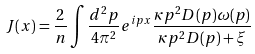<formula> <loc_0><loc_0><loc_500><loc_500>J ( x ) = \frac { 2 } { n } \int \frac { d ^ { 2 } p } { 4 \pi ^ { 2 } } e ^ { i p x } \frac { \kappa p ^ { 2 } D ( p ) \omega ( p ) } { \kappa p ^ { 2 } D ( p ) + \xi }</formula> 